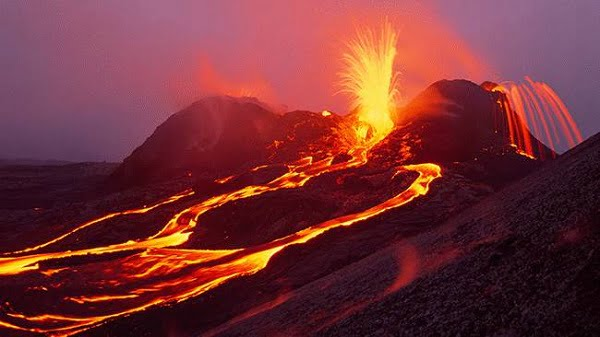What safety measures are typically in place for visitors at sites like Hawaii Volcanoes National Park during an eruption? Safety measures at sites like Hawaii Volcanoes National Park include restricted access to eruption zones, real-time monitoring of volcanic activity, and evacuation plans. Tourists are provided with safety information through park rangers and signage. Moreover, measures such as designated viewing areas that are at a safe distance yet offer a clear view of the eruption are often implemented to ensure visitor safety while allowing them to experience the natural phenomenon. 